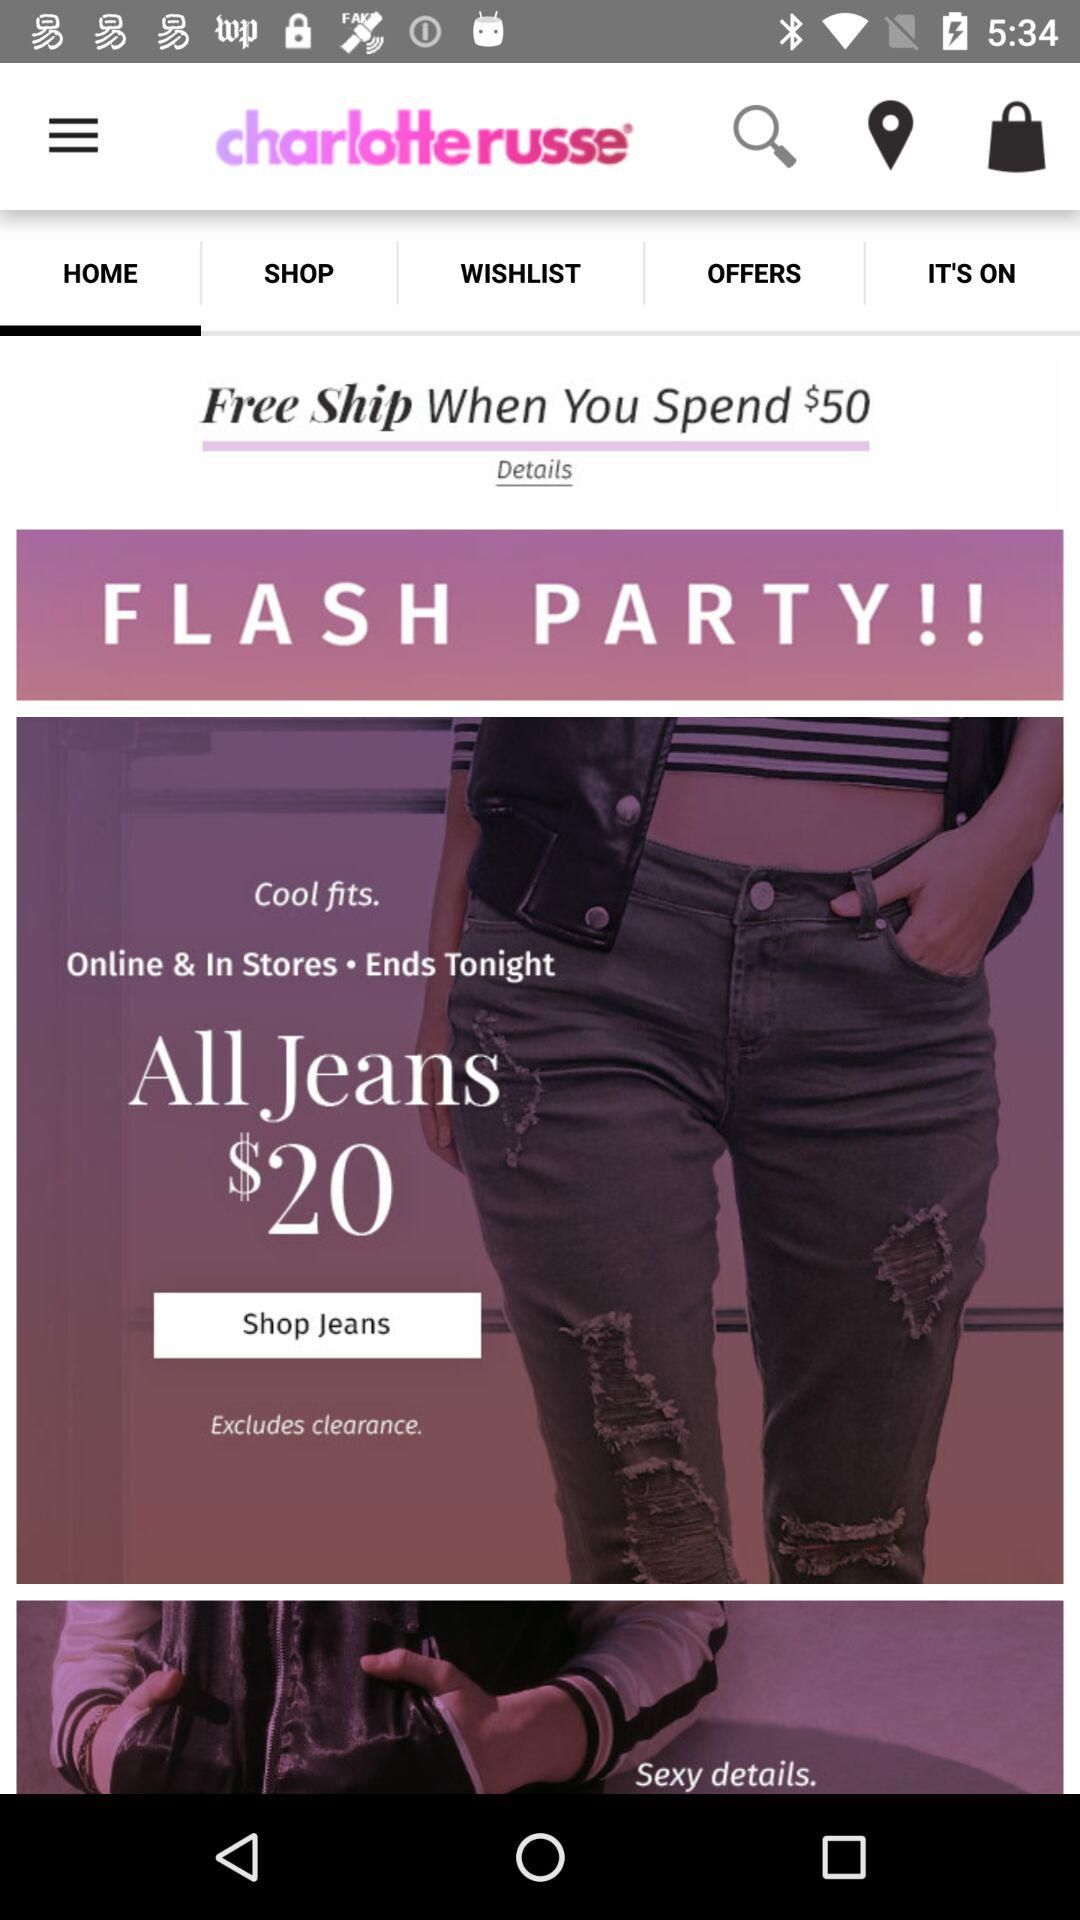When will this offer end? The offer will end tonight. 